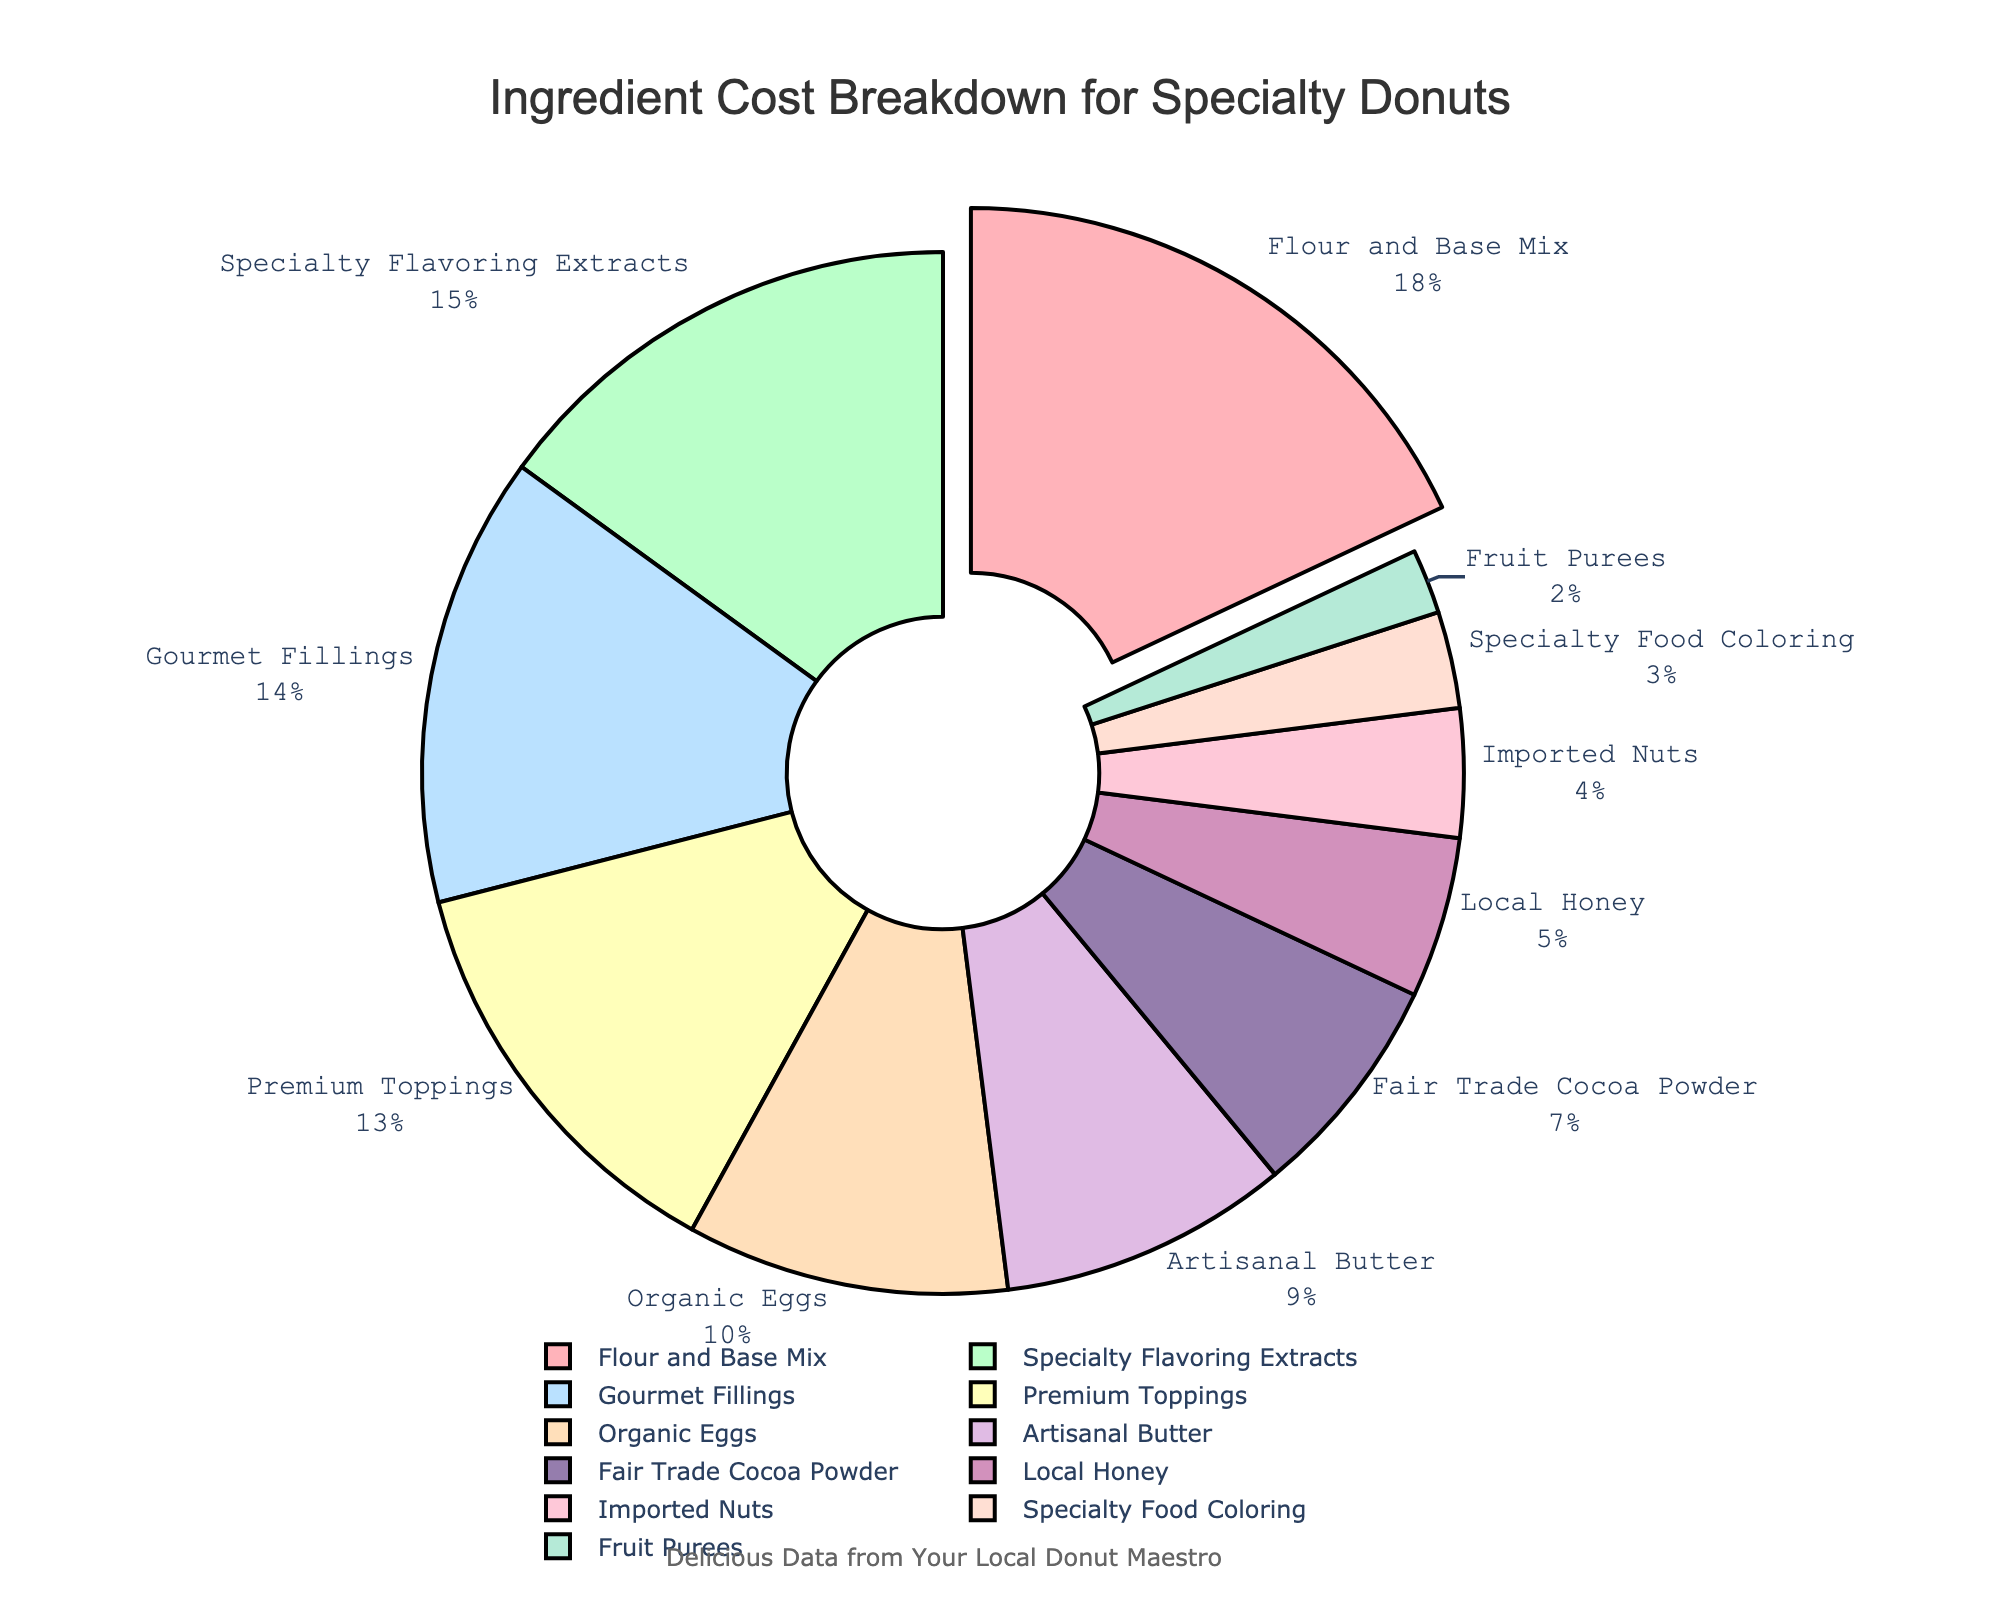What is the percentage of the most expensive ingredient? Looking at the figure, the most expensive ingredient is highlighted by being slightly pulled out from the pie chart. The label on this section indicates it's "Flour and Base Mix" with a cost percentage of 18%.
Answer: 18% Which ingredient has the lowest cost percentage and what is it? Based on the labels and their corresponding percentages, "Fruit Purees" has the lowest cost percentage at 2%.
Answer: Fruit Purees How much more expensive is the "Specialty Flavoring Extracts" compared to "Imported Nuts"? From the figure, "Specialty Flavoring Extracts" is listed with a 15% cost, and "Imported Nuts" is at 4%. Subtract the cost percentage of "Imported Nuts" from "Specialty Flavoring Extracts" (15% - 4%).
Answer: 11% What is the combined cost percentage of "Gourmet Fillings" and "Premium Toppings"? The cost percentage for "Gourmet Fillings" is 14%, and for "Premium Toppings" it's 13%. Add these values together to get the total combined cost percentage (14% + 13%).
Answer: 27% How many ingredients have a cost percentage greater than 10%? By scanning the labels, the following ingredients have a cost percentage greater than 10%: "Flour and Base Mix" (18%), "Specialty Flavoring Extracts" (15%), "Gourmet Fillings" (14%), and "Premium Toppings" (13%). Count these items.
Answer: 4 If you combine the cost percentages of "Organic Eggs," "Artisanal Butter," and "Local Honey," what is their total percentage? "Organic Eggs" have a cost percentage of 10%, "Artisanal Butter" is at 9%, and "Local Honey" is 5%. Sum these percentages to get the total (10% + 9% + 5%).
Answer: 24% Which ingredients have costs less than 5% and what are their total combined cost percentages? The ingredients with costs less than 5% are "Imported Nuts" (4%), "Specialty Food Coloring" (3%), and "Fruit Purees" (2%). Sum these values to get their total (4% + 3% + 2%).
Answer: 9% Compare the cost percentage of "Fair Trade Cocoa Powder" to "Artisanal Butter." Which one is more expensive and by how much? "Fair Trade Cocoa Powder" has a cost percentage of 7%, while "Artisanal Butter" is at 9%. Subtract the cost percentage of "Fair Trade Cocoa Powder" from "Artisanal Butter" (9% - 7%).
Answer: Artisanal Butter, 2% What is the average cost percentage of "Specialty Flavoring Extracts," "Premium Toppings," and "Fair Trade Cocoa Powder"? The cost percentages are 15% for "Specialty Flavoring Extracts," 13% for "Premium Toppings," and 7% for "Fair Trade Cocoa Powder." Sum these values and then divide by the number of ingredients to get the average ((15% + 13% + 7%) / 3).
Answer: 11.67% Which ingredient is represented by the color green? Scan the figure for the green section of the pie chart and look at the associated label. The green color corresponds to "Specialty Flavoring Extracts."
Answer: Specialty Flavoring Extracts 